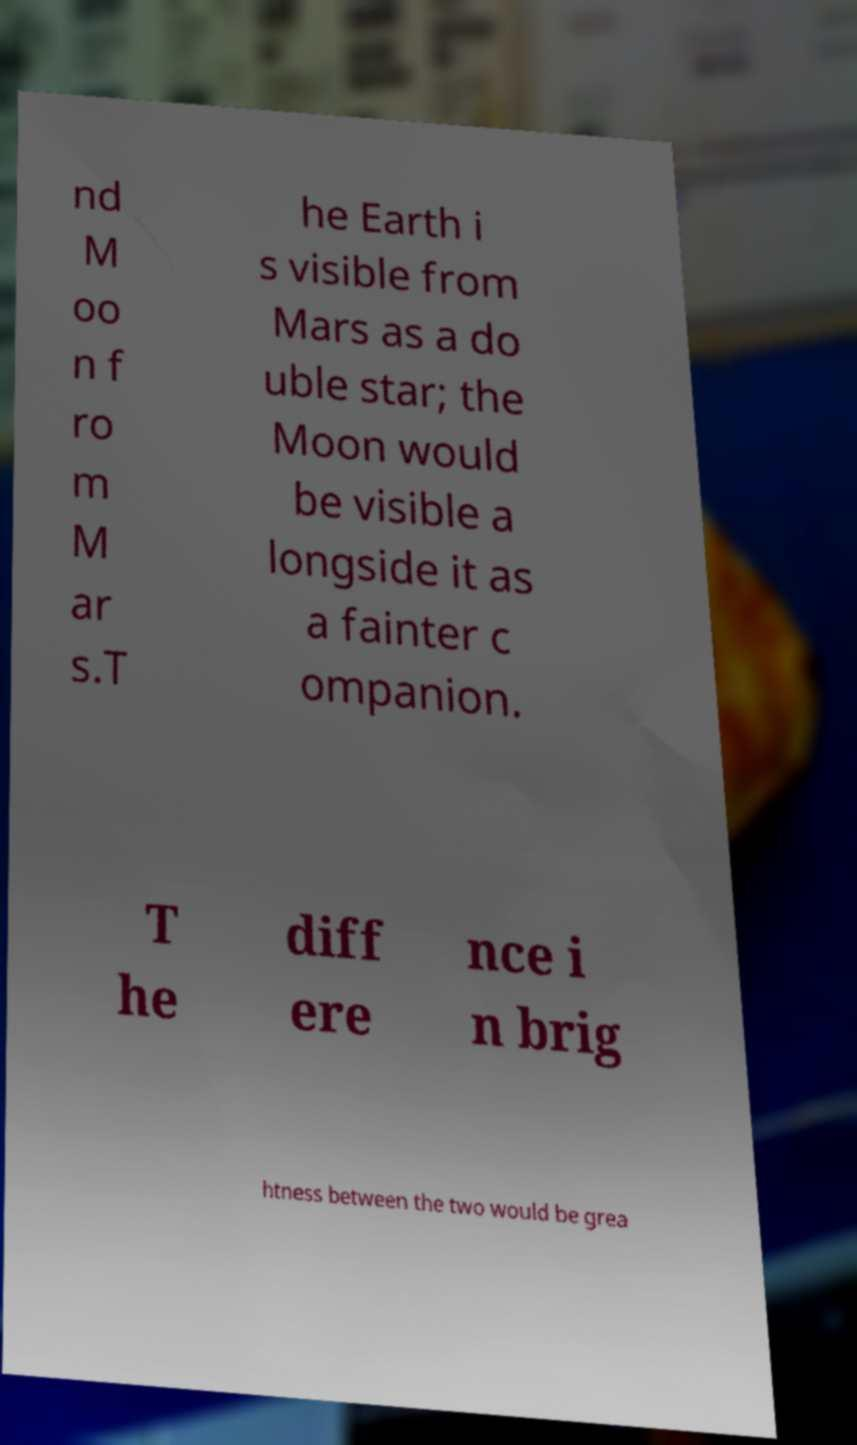Could you extract and type out the text from this image? nd M oo n f ro m M ar s.T he Earth i s visible from Mars as a do uble star; the Moon would be visible a longside it as a fainter c ompanion. T he diff ere nce i n brig htness between the two would be grea 